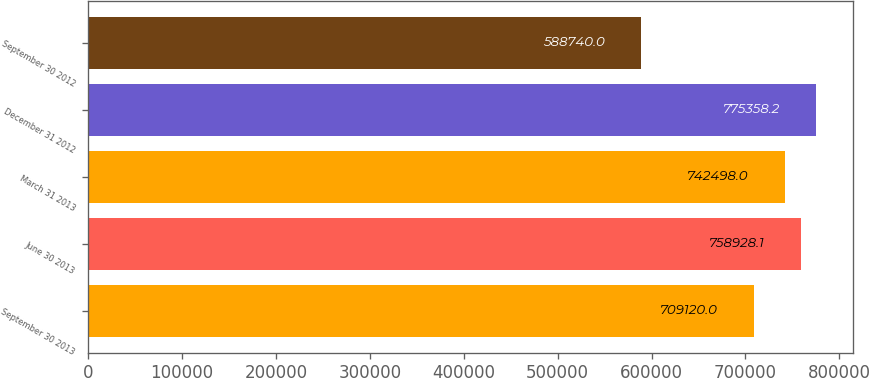<chart> <loc_0><loc_0><loc_500><loc_500><bar_chart><fcel>September 30 2013<fcel>June 30 2013<fcel>March 31 2013<fcel>December 31 2012<fcel>September 30 2012<nl><fcel>709120<fcel>758928<fcel>742498<fcel>775358<fcel>588740<nl></chart> 